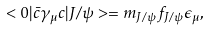Convert formula to latex. <formula><loc_0><loc_0><loc_500><loc_500>< 0 | \bar { c } \gamma _ { \mu } c | J / \psi > = m _ { J / \psi } f _ { J / \psi } \epsilon _ { \mu } ,</formula> 